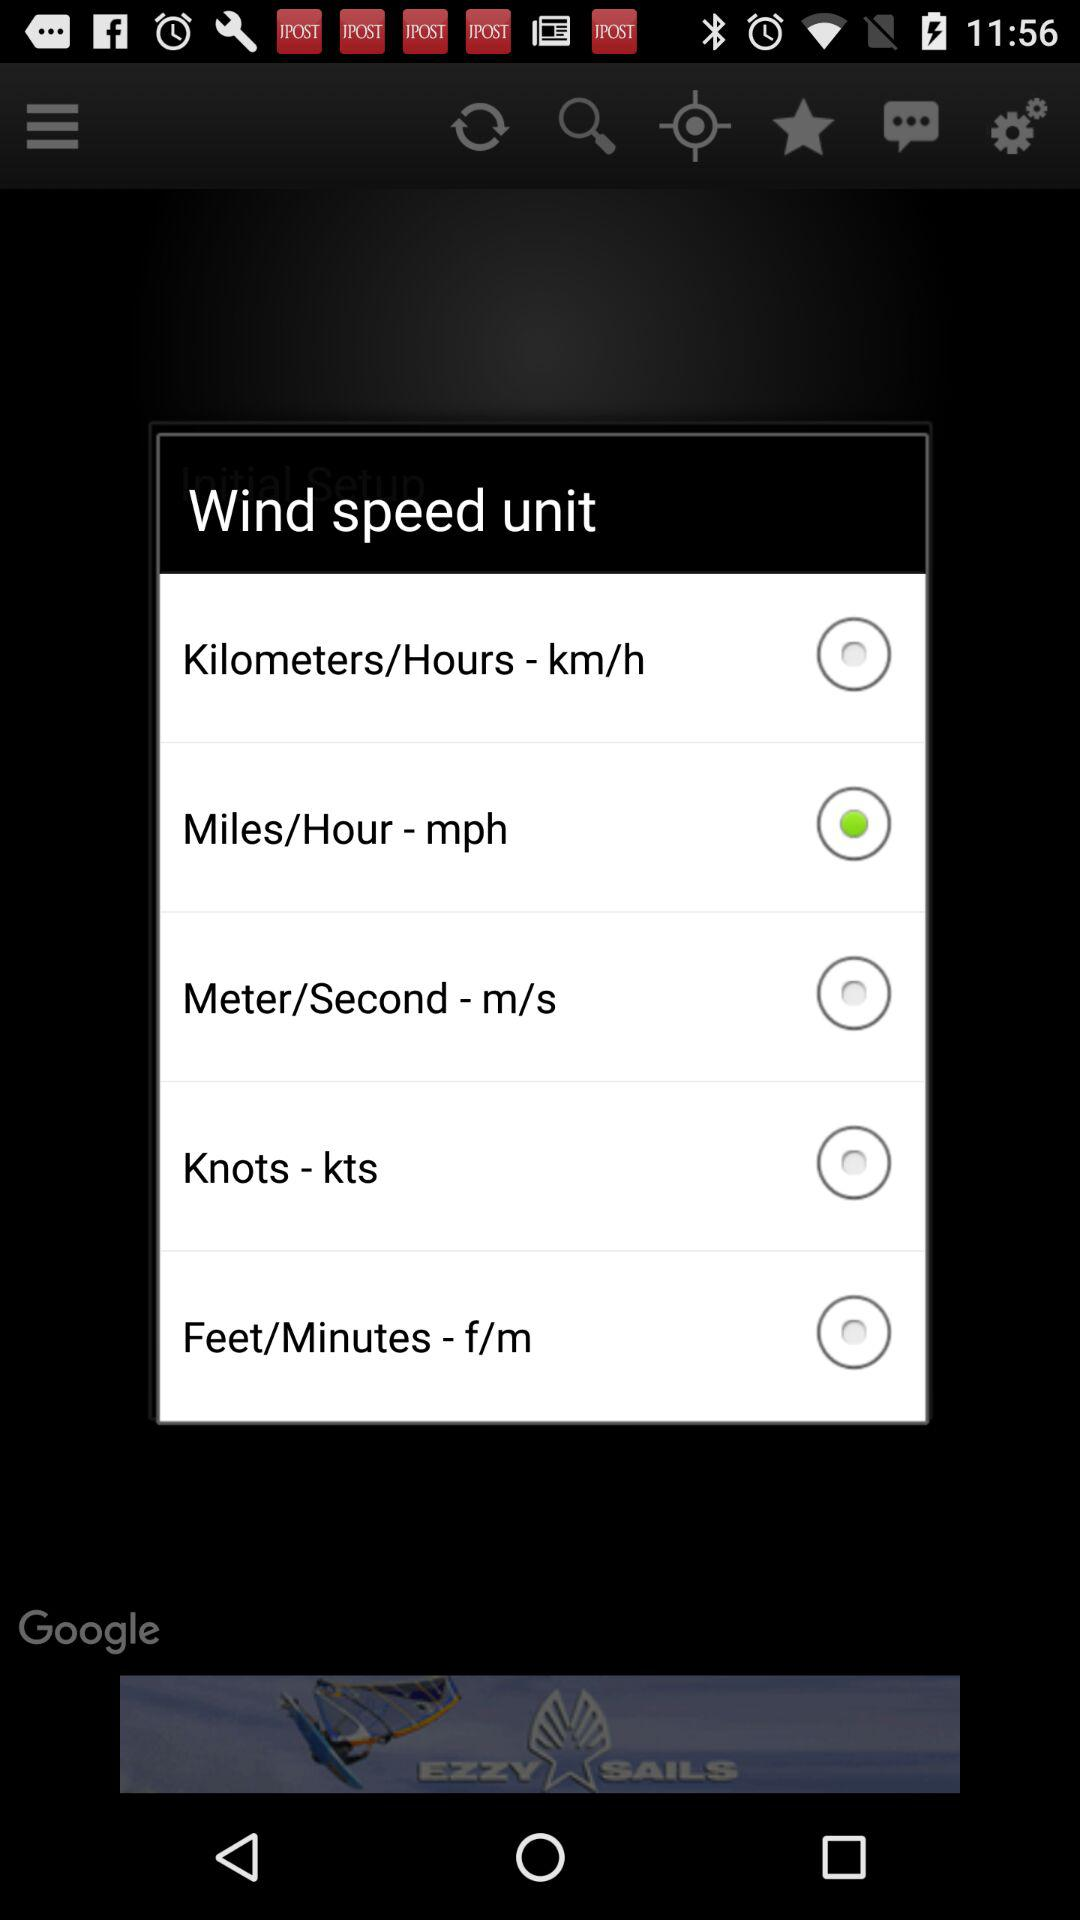How many units are there for wind speed?
Answer the question using a single word or phrase. 5 